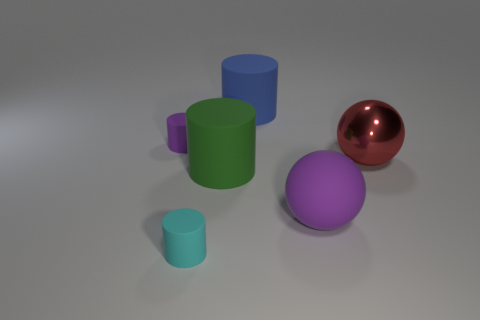Subtract 1 cylinders. How many cylinders are left? 3 Add 3 big purple balls. How many objects exist? 9 Subtract all cylinders. How many objects are left? 2 Add 2 big metal objects. How many big metal objects exist? 3 Subtract 1 cyan cylinders. How many objects are left? 5 Subtract all tiny metal things. Subtract all red metallic things. How many objects are left? 5 Add 4 large red metallic balls. How many large red metallic balls are left? 5 